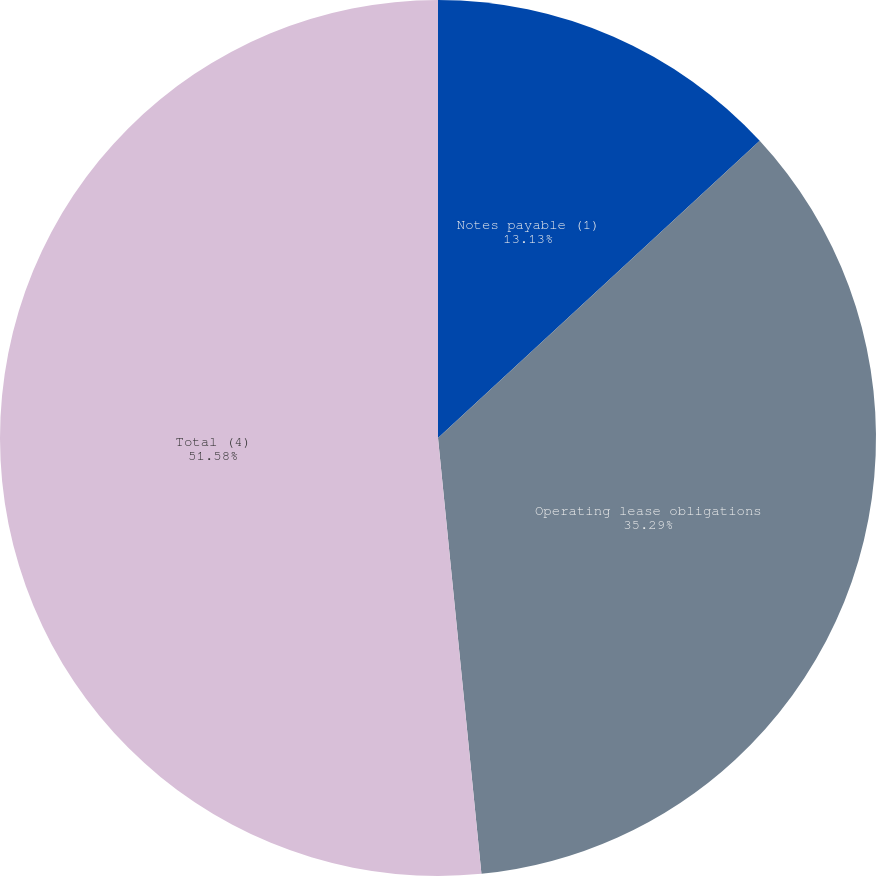Convert chart to OTSL. <chart><loc_0><loc_0><loc_500><loc_500><pie_chart><fcel>Notes payable (1)<fcel>Operating lease obligations<fcel>Total (4)<nl><fcel>13.13%<fcel>35.29%<fcel>51.58%<nl></chart> 